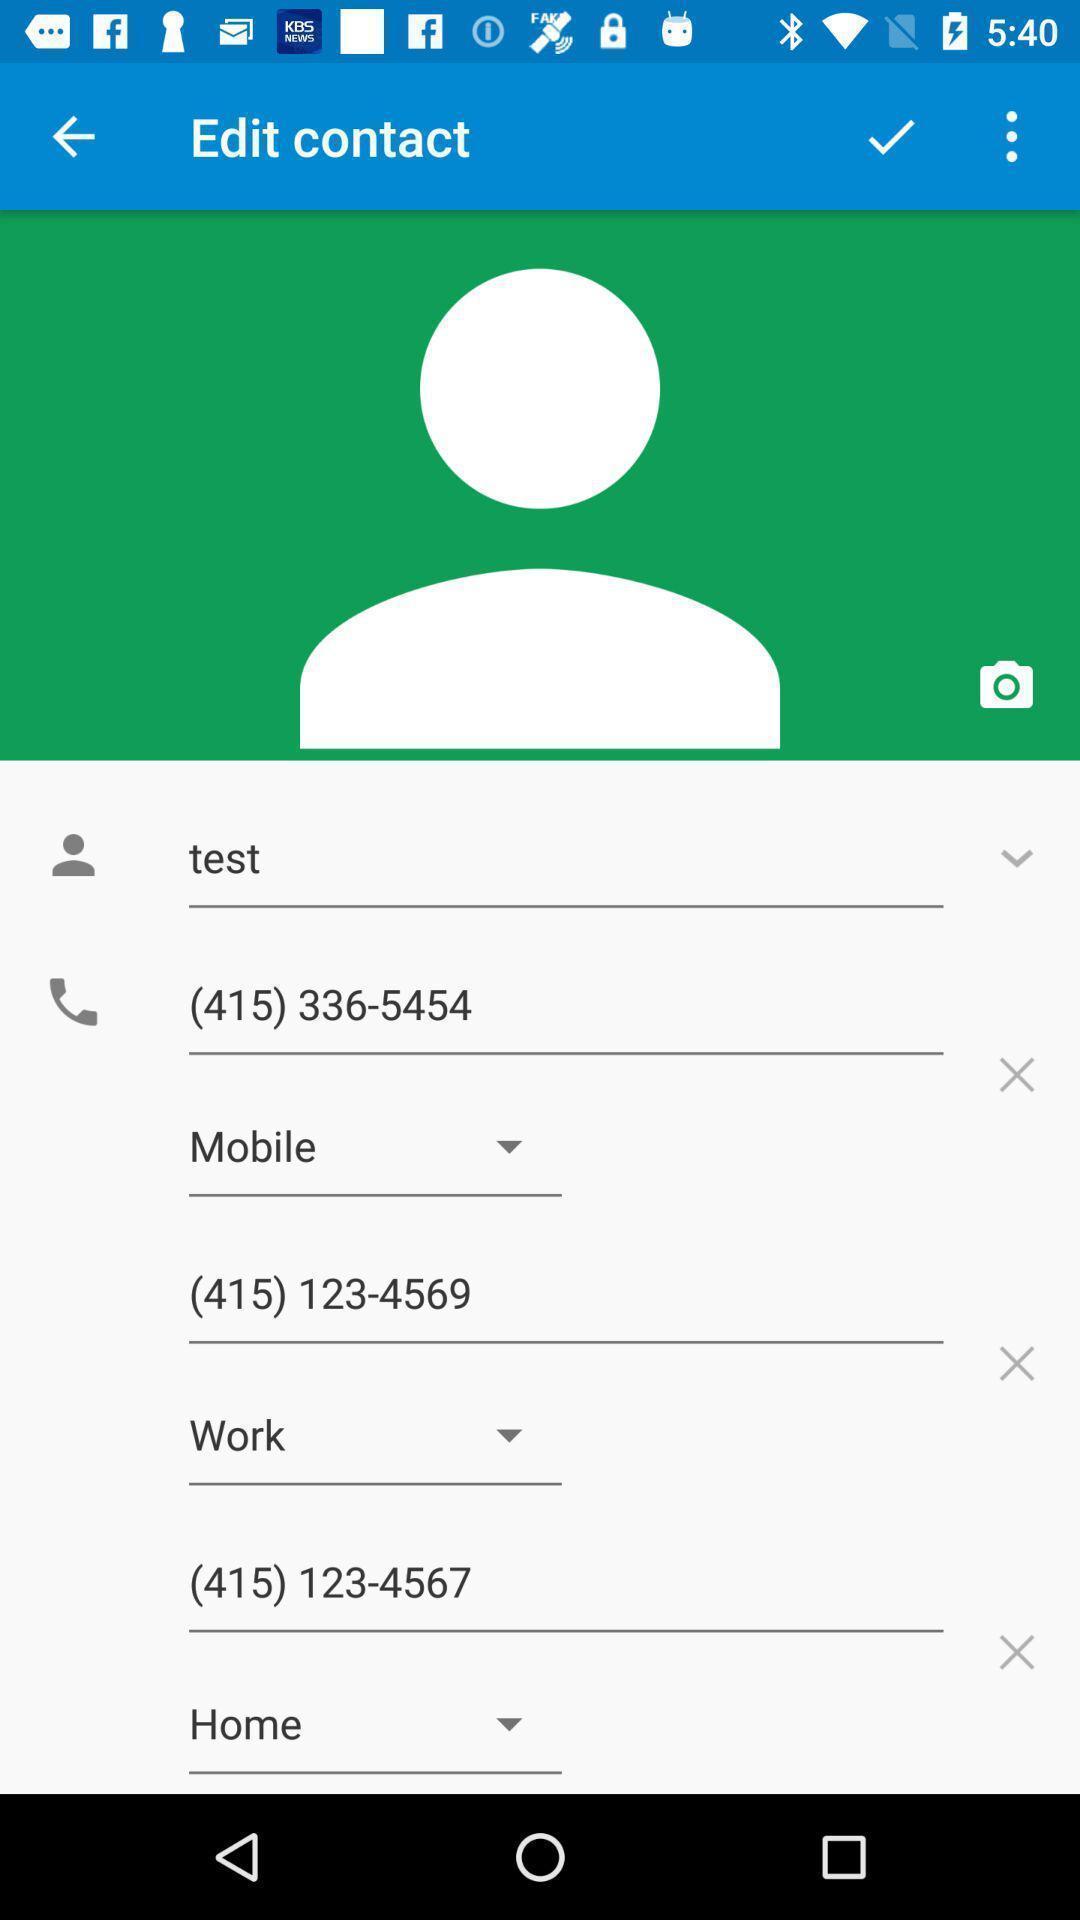Describe the visual elements of this screenshot. Page displays to edit contact in app. 